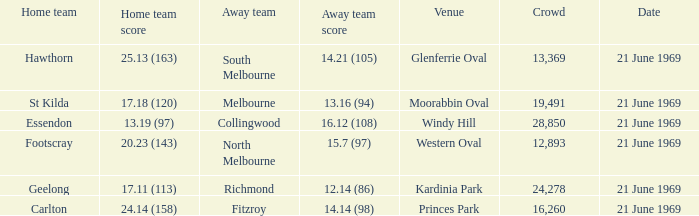What is Essendon's home team that has an away crowd size larger than 19,491? Collingwood. 